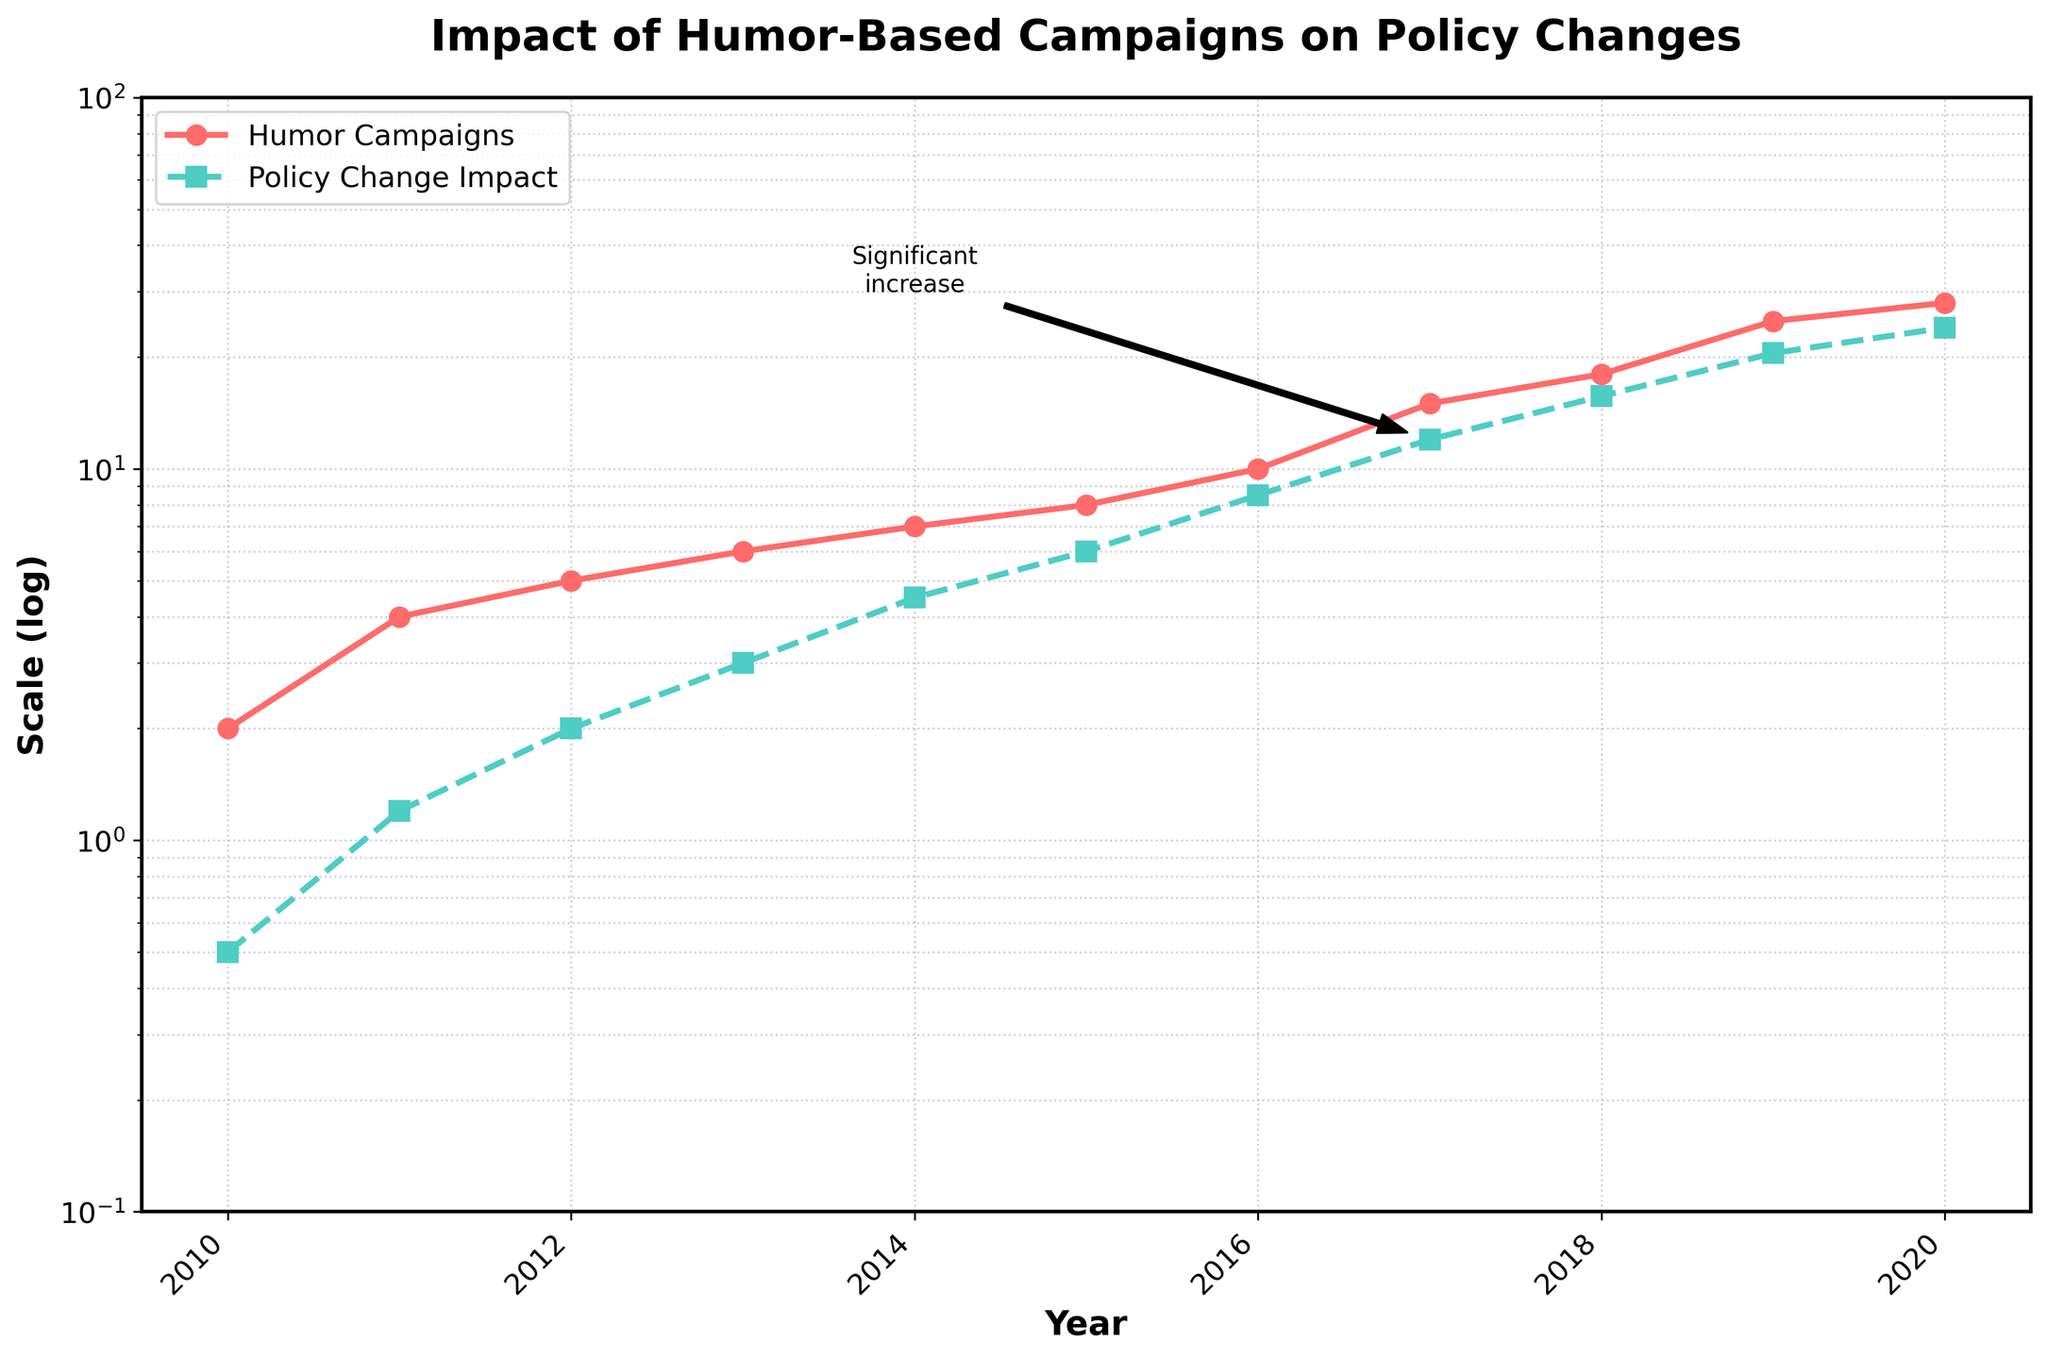What's the title of the figure? The title of the figure is written at the top of the plot.
Answer: Impact of Humor-Based Campaigns on Policy Changes How many data points are there in total? There are markers on the lines that denote each data point. Counting them for either line will give the total number of data points.
Answer: 11 Which year shows the highest number of Humor Campaigns? The year with the highest plotted value for the red line (Humor Campaigns) indicates the highest number of campaigns.
Answer: 2020 What kind of label does the y-axis have? The y-axis label is written on the side of the axis.
Answer: Scale (log) By how much did the Policy Change Impact increase from 2017 to 2020? Subtract the value of Policy Change Impact for 2017 from the value for 2020. According to the chart, 2020 has an impact value of 24.0, and 2017 has 12.0.
Answer: 12.0 On a logarithmic scale, what is the range of the y-axis? The range of the y-axis is shown on the axis itself, from the minimum to the maximum values.
Answer: 0.1 to 100 Which year is annotated with "Significant increase" in the Policy Change Impact? The annotation on the graph marks significant events, which can be matched to the relevant year.
Answer: 2017 What year marks the first time the number of Humor Campaigns exceeded 20? Identifying where the red line first crosses the 20 mark on the y-axis by looking at the plotted points.
Answer: 2019 What is the approximate impact on policy change in the year humor campaigns reached 25? Locate the year Humor Campaigns reach 25 on the red line and refer to the blue line for the corresponding impact value.
Answer: 20.5 What is the difference between Humor Campaigns and Policy Change Impact in 2012? Refer to both lines for the year 2012 and subtract the Policy Change Impact value from the Humor Campaigns value.
Answer: 3.0 How are the Humor Campaigns and Policy Change Impact trends related over the years? Look at the general trend and relationship between the two lines over multiple years to observe how they move.
Answer: Both are increasing consistently 